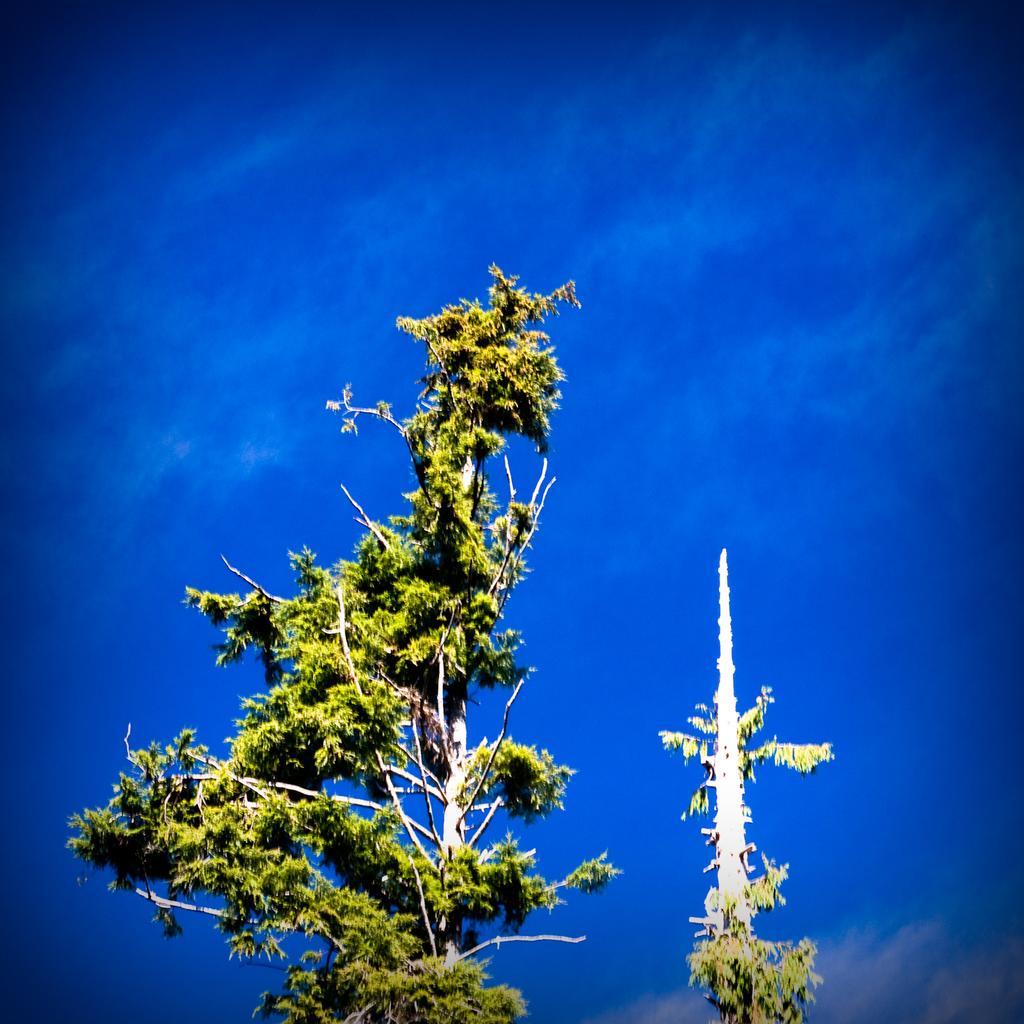Could you give a brief overview of what you see in this image? In the center of the image we can see trees. In the background there is a sky. 